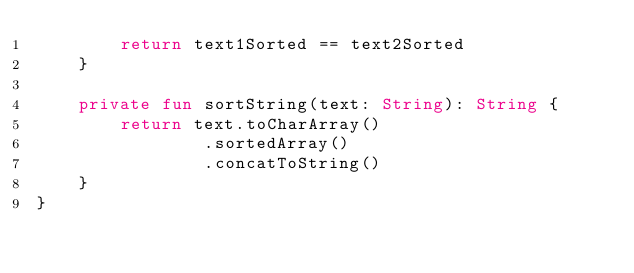Convert code to text. <code><loc_0><loc_0><loc_500><loc_500><_Kotlin_>        return text1Sorted == text2Sorted
    }

    private fun sortString(text: String): String {
        return text.toCharArray()
                .sortedArray()
                .concatToString()
    }
}
</code> 